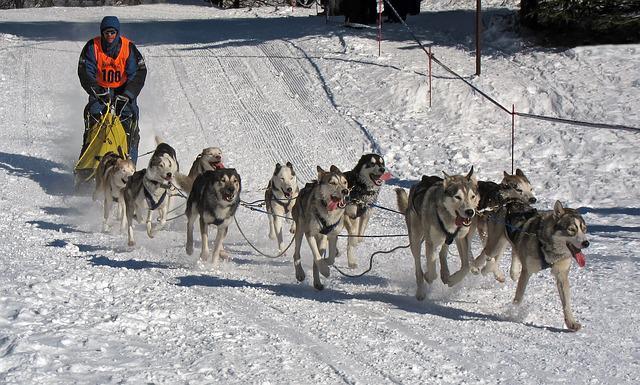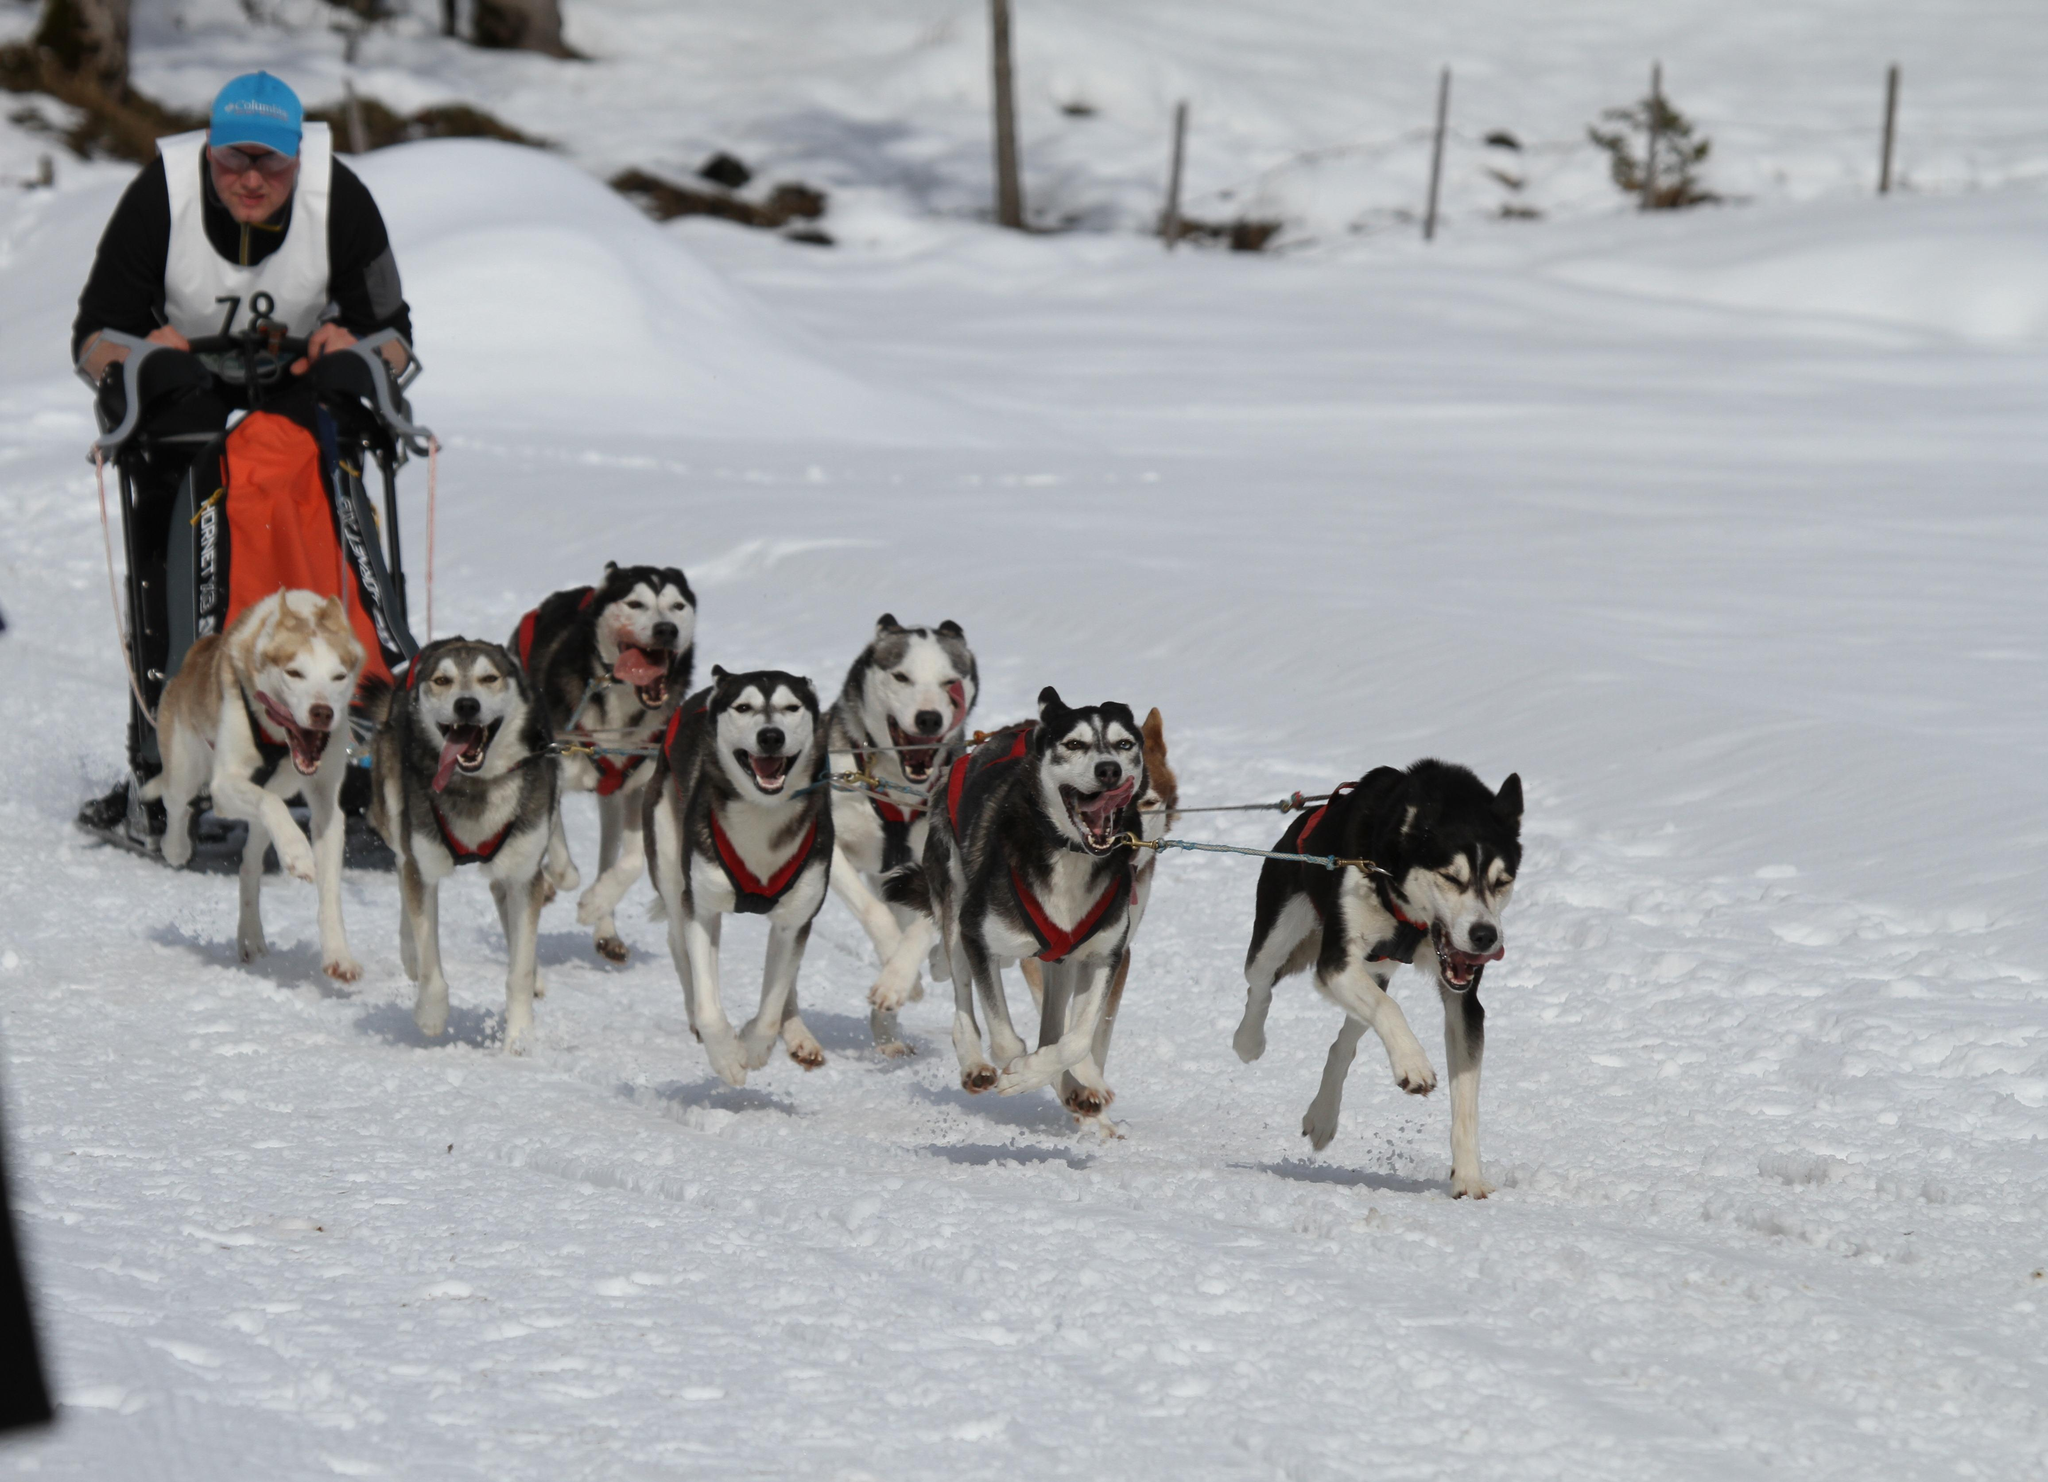The first image is the image on the left, the second image is the image on the right. Assess this claim about the two images: "An image shows a sled driver on the right behind a team of dogs facing the camera.". Correct or not? Answer yes or no. No. The first image is the image on the left, the second image is the image on the right. For the images shown, is this caption "Only one rider is visible with the dogs." true? Answer yes or no. No. 